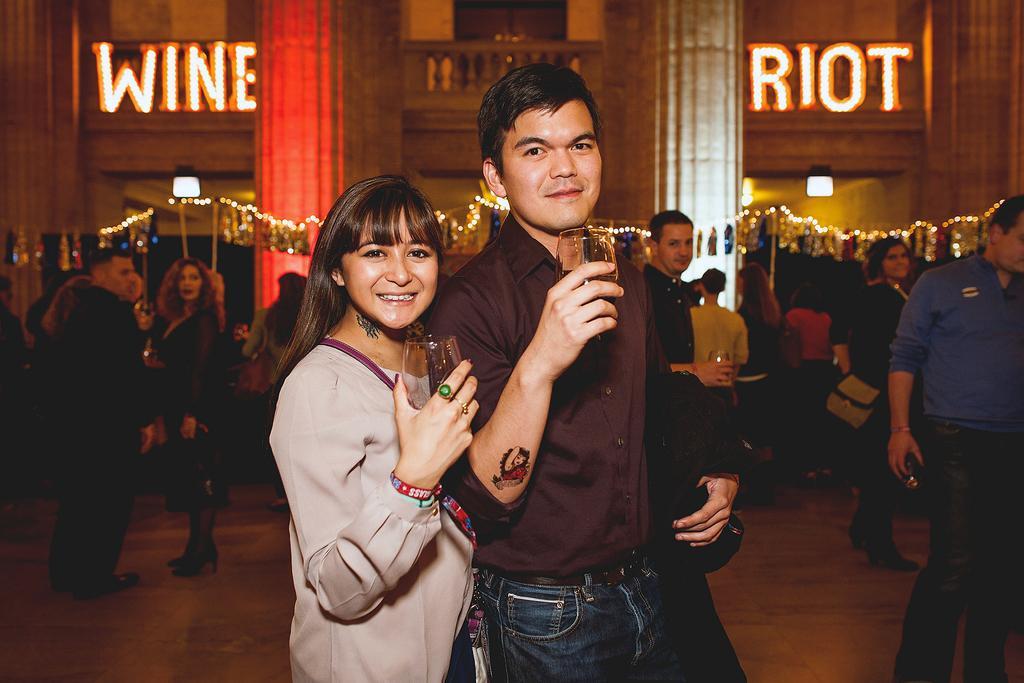Please provide a concise description of this image. In this image I see a man and a woman who are smiling and I see that both of them are holding glasses in their hands and I see a tattoo on this hand and I see another tattoo on the neck of this woman and in the background I see number of people, lights, 2 words written on the wall and I see the path. 